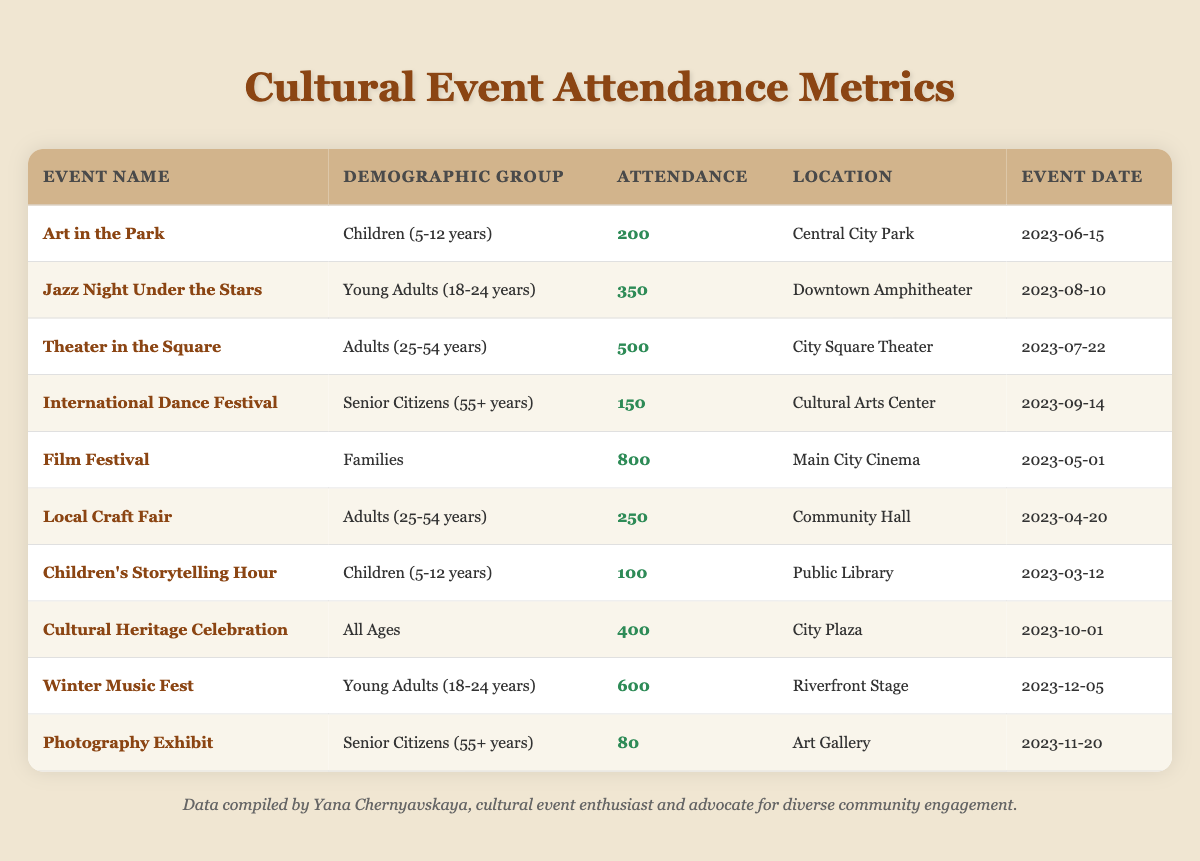What was the attendance for "Film Festival"? The table indicates the event name "Film Festival" with a corresponding attendance value of 800.
Answer: 800 Which demographic group had the highest attendance at an event? Reviewing the attendance data, "Families" had the highest attendance at the "Film Festival" with 800 attendees.
Answer: Families What is the attendance for the event "Jazz Night Under the Stars"? The table shows that the attendance for "Jazz Night Under the Stars" is 350.
Answer: 350 How many events were targeted at "Children (5-12 years)" demographic? The table shows two events: "Art in the Park" and "Children's Storytelling Hour". Hence, there are 2 events for this demographic.
Answer: 2 What is the total attendance for all events aimed at "Young Adults (18-24 years)"? Adding the attendance for "Jazz Night Under the Stars" (350) and "Winter Music Fest" (600) gives a total of 950 attendees for this demographic.
Answer: 950 Is the attendance for "Photography Exhibit" greater than 100? The table states that the attendance for "Photography Exhibit" is 80, which is less than 100.
Answer: No What was the location of the event with the lowest attendance? The attendance for "Photography Exhibit" is 80, which is the lowest, and its location is "Art Gallery".
Answer: Art Gallery Which event had attendance greater than 400? The "Film Festival" (800) and "Winter Music Fest" (600) both had attendance greater than 400.
Answer: Film Festival, Winter Music Fest What is the average attendance for events aimed at "Senior Citizens (55+ years)"? The events "International Dance Festival" had 150 and "Photography Exhibit" had 80. The total is 230, and the average attendance for these two events is 230/2 = 115.
Answer: 115 Which event happened at "City Plaza"? The table indicates that the "Cultural Heritage Celebration" event took place at "City Plaza".
Answer: Cultural Heritage Celebration 